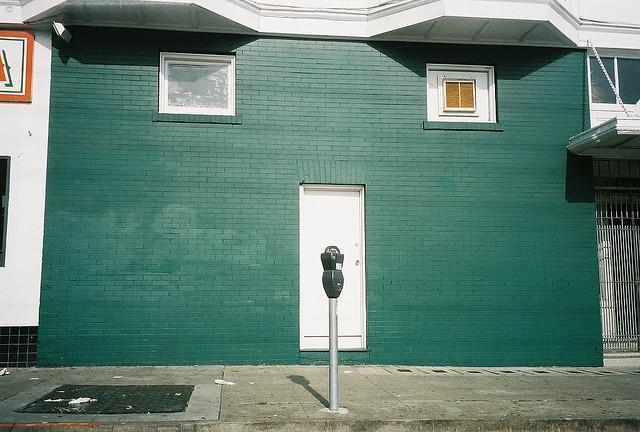How many treetops are visible?
Give a very brief answer. 0. How many people are on the motorcycle?
Give a very brief answer. 0. 